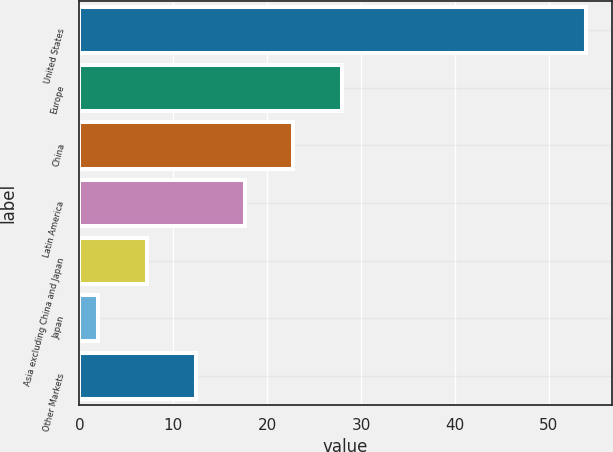<chart> <loc_0><loc_0><loc_500><loc_500><bar_chart><fcel>United States<fcel>Europe<fcel>China<fcel>Latin America<fcel>Asia excluding China and Japan<fcel>Japan<fcel>Other Markets<nl><fcel>54<fcel>28<fcel>22.8<fcel>17.6<fcel>7.2<fcel>2<fcel>12.4<nl></chart> 